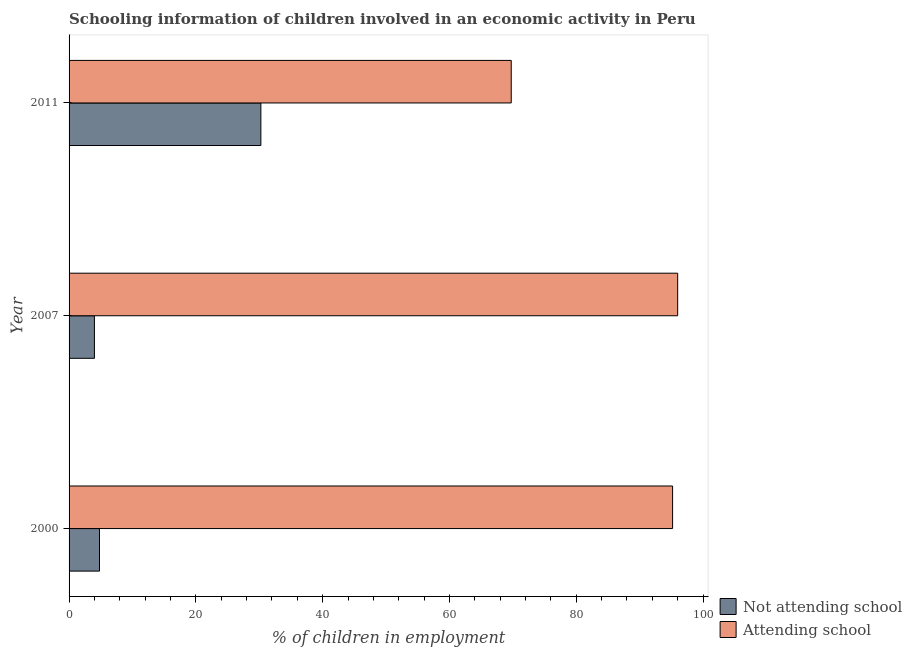How many different coloured bars are there?
Make the answer very short. 2. Are the number of bars per tick equal to the number of legend labels?
Give a very brief answer. Yes. How many bars are there on the 1st tick from the top?
Offer a terse response. 2. How many bars are there on the 3rd tick from the bottom?
Give a very brief answer. 2. What is the label of the 1st group of bars from the top?
Provide a short and direct response. 2011. In how many cases, is the number of bars for a given year not equal to the number of legend labels?
Your response must be concise. 0. What is the percentage of employed children who are attending school in 2000?
Your answer should be very brief. 95.2. Across all years, what is the maximum percentage of employed children who are not attending school?
Your answer should be compact. 30.25. In which year was the percentage of employed children who are not attending school minimum?
Make the answer very short. 2007. What is the total percentage of employed children who are not attending school in the graph?
Provide a succinct answer. 39.05. What is the difference between the percentage of employed children who are not attending school in 2007 and that in 2011?
Provide a succinct answer. -26.25. What is the difference between the percentage of employed children who are attending school in 2011 and the percentage of employed children who are not attending school in 2007?
Offer a terse response. 65.75. What is the average percentage of employed children who are attending school per year?
Offer a terse response. 86.98. In the year 2007, what is the difference between the percentage of employed children who are attending school and percentage of employed children who are not attending school?
Ensure brevity in your answer.  92. What is the ratio of the percentage of employed children who are not attending school in 2007 to that in 2011?
Offer a very short reply. 0.13. Is the percentage of employed children who are not attending school in 2000 less than that in 2007?
Provide a succinct answer. No. What is the difference between the highest and the lowest percentage of employed children who are attending school?
Your answer should be very brief. 26.25. In how many years, is the percentage of employed children who are not attending school greater than the average percentage of employed children who are not attending school taken over all years?
Offer a terse response. 1. What does the 2nd bar from the top in 2011 represents?
Keep it short and to the point. Not attending school. What does the 2nd bar from the bottom in 2000 represents?
Offer a terse response. Attending school. Are all the bars in the graph horizontal?
Give a very brief answer. Yes. Are the values on the major ticks of X-axis written in scientific E-notation?
Offer a terse response. No. Does the graph contain any zero values?
Your response must be concise. No. Does the graph contain grids?
Give a very brief answer. No. Where does the legend appear in the graph?
Provide a succinct answer. Bottom right. How many legend labels are there?
Keep it short and to the point. 2. What is the title of the graph?
Offer a very short reply. Schooling information of children involved in an economic activity in Peru. Does "Male labourers" appear as one of the legend labels in the graph?
Offer a terse response. No. What is the label or title of the X-axis?
Make the answer very short. % of children in employment. What is the label or title of the Y-axis?
Your answer should be compact. Year. What is the % of children in employment of Not attending school in 2000?
Ensure brevity in your answer.  4.8. What is the % of children in employment in Attending school in 2000?
Make the answer very short. 95.2. What is the % of children in employment of Not attending school in 2007?
Ensure brevity in your answer.  4. What is the % of children in employment in Attending school in 2007?
Your answer should be very brief. 96. What is the % of children in employment in Not attending school in 2011?
Provide a short and direct response. 30.25. What is the % of children in employment in Attending school in 2011?
Your response must be concise. 69.75. Across all years, what is the maximum % of children in employment of Not attending school?
Your answer should be very brief. 30.25. Across all years, what is the maximum % of children in employment of Attending school?
Give a very brief answer. 96. Across all years, what is the minimum % of children in employment in Attending school?
Provide a succinct answer. 69.75. What is the total % of children in employment of Not attending school in the graph?
Keep it short and to the point. 39.05. What is the total % of children in employment of Attending school in the graph?
Give a very brief answer. 260.95. What is the difference between the % of children in employment in Attending school in 2000 and that in 2007?
Your answer should be compact. -0.8. What is the difference between the % of children in employment of Not attending school in 2000 and that in 2011?
Your answer should be compact. -25.45. What is the difference between the % of children in employment in Attending school in 2000 and that in 2011?
Ensure brevity in your answer.  25.45. What is the difference between the % of children in employment in Not attending school in 2007 and that in 2011?
Your answer should be very brief. -26.25. What is the difference between the % of children in employment in Attending school in 2007 and that in 2011?
Give a very brief answer. 26.25. What is the difference between the % of children in employment of Not attending school in 2000 and the % of children in employment of Attending school in 2007?
Give a very brief answer. -91.2. What is the difference between the % of children in employment of Not attending school in 2000 and the % of children in employment of Attending school in 2011?
Your answer should be compact. -64.95. What is the difference between the % of children in employment of Not attending school in 2007 and the % of children in employment of Attending school in 2011?
Give a very brief answer. -65.75. What is the average % of children in employment of Not attending school per year?
Offer a very short reply. 13.02. What is the average % of children in employment of Attending school per year?
Offer a terse response. 86.98. In the year 2000, what is the difference between the % of children in employment of Not attending school and % of children in employment of Attending school?
Your response must be concise. -90.4. In the year 2007, what is the difference between the % of children in employment in Not attending school and % of children in employment in Attending school?
Your response must be concise. -92. In the year 2011, what is the difference between the % of children in employment of Not attending school and % of children in employment of Attending school?
Make the answer very short. -39.49. What is the ratio of the % of children in employment of Attending school in 2000 to that in 2007?
Your answer should be compact. 0.99. What is the ratio of the % of children in employment of Not attending school in 2000 to that in 2011?
Give a very brief answer. 0.16. What is the ratio of the % of children in employment in Attending school in 2000 to that in 2011?
Ensure brevity in your answer.  1.36. What is the ratio of the % of children in employment in Not attending school in 2007 to that in 2011?
Your response must be concise. 0.13. What is the ratio of the % of children in employment of Attending school in 2007 to that in 2011?
Offer a very short reply. 1.38. What is the difference between the highest and the second highest % of children in employment in Not attending school?
Offer a very short reply. 25.45. What is the difference between the highest and the second highest % of children in employment of Attending school?
Offer a very short reply. 0.8. What is the difference between the highest and the lowest % of children in employment in Not attending school?
Make the answer very short. 26.25. What is the difference between the highest and the lowest % of children in employment in Attending school?
Keep it short and to the point. 26.25. 